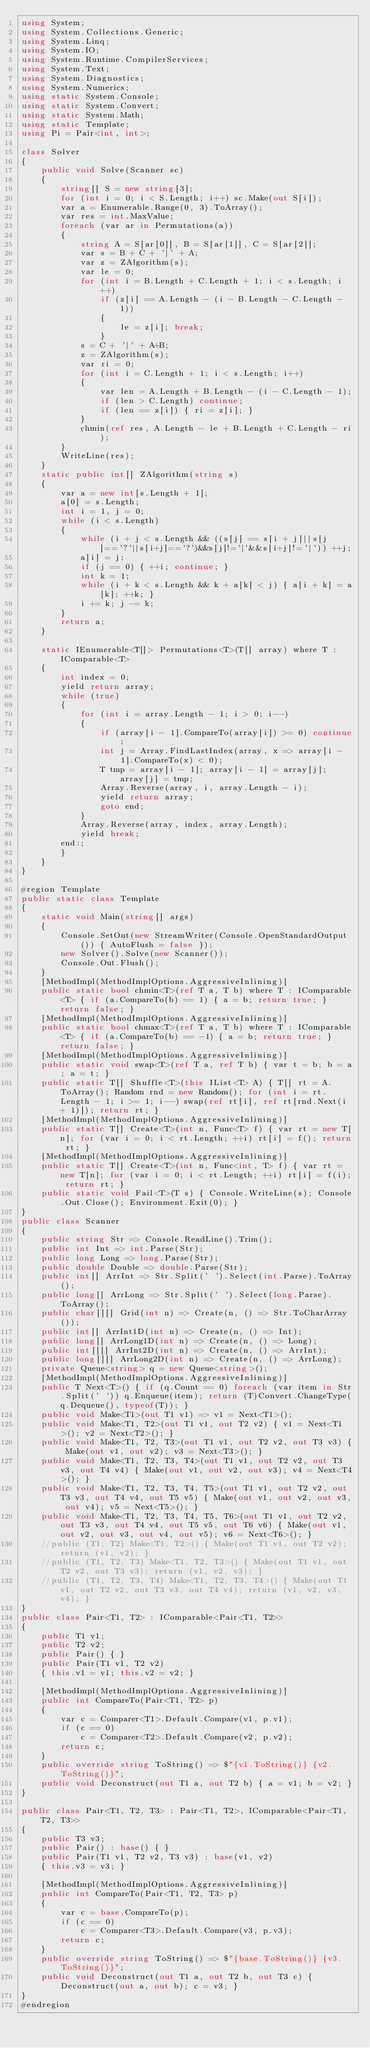<code> <loc_0><loc_0><loc_500><loc_500><_C#_>using System;
using System.Collections.Generic;
using System.Linq;
using System.IO;
using System.Runtime.CompilerServices;
using System.Text;
using System.Diagnostics;
using System.Numerics;
using static System.Console;
using static System.Convert;
using static System.Math;
using static Template;
using Pi = Pair<int, int>;

class Solver
{
    public void Solve(Scanner sc)
    {
        string[] S = new string[3];
        for (int i = 0; i < S.Length; i++) sc.Make(out S[i]);
        var a = Enumerable.Range(0, 3).ToArray();
        var res = int.MaxValue;
        foreach (var ar in Permutations(a))
        {
            string A = S[ar[0]], B = S[ar[1]], C = S[ar[2]];
            var s = B + C + '|' + A;
            var z = ZAlgorithm(s);
            var le = 0;
            for (int i = B.Length + C.Length + 1; i < s.Length; i++)
                if (z[i] == A.Length - (i - B.Length - C.Length - 1))
                {
                    le = z[i]; break;
                }
            s = C + '|' + A+B;
            z = ZAlgorithm(s);
            var ri = 0;
            for (int i = C.Length + 1; i < s.Length; i++)
            {
                var len = A.Length + B.Length - (i - C.Length - 1);
                if (len > C.Length) continue;
                if (len == z[i]) { ri = z[i]; }
            }
            chmin(ref res, A.Length - le + B.Length + C.Length - ri);
        }
        WriteLine(res);
    }
    static public int[] ZAlgorithm(string s)
    {
        var a = new int[s.Length + 1];
        a[0] = s.Length;
        int i = 1, j = 0;
        while (i < s.Length)
        {
            while (i + j < s.Length && ((s[j] == s[i + j]||s[j]=='?'||s[i+j]=='?')&&s[j]!='|'&&s[i+j]!='|')) ++j;
            a[i] = j;
            if (j == 0) { ++i; continue; }
            int k = 1;
            while (i + k < s.Length && k + a[k] < j) { a[i + k] = a[k]; ++k; }
            i += k; j -= k;
        }
        return a;
    }

    static IEnumerable<T[]> Permutations<T>(T[] array) where T : IComparable<T>
    {
        int index = 0;
        yield return array;
        while (true)
        {
            for (int i = array.Length - 1; i > 0; i--)
            {
                if (array[i - 1].CompareTo(array[i]) >= 0) continue;
                int j = Array.FindLastIndex(array, x => array[i - 1].CompareTo(x) < 0);
                T tmp = array[i - 1]; array[i - 1] = array[j]; array[j] = tmp;
                Array.Reverse(array, i, array.Length - i);
                yield return array;
                goto end;
            }
            Array.Reverse(array, index, array.Length);
            yield break;
        end:;
        }
    }
}

#region Template
public static class Template
{
    static void Main(string[] args)
    {
        Console.SetOut(new StreamWriter(Console.OpenStandardOutput()) { AutoFlush = false });
        new Solver().Solve(new Scanner());
        Console.Out.Flush();
    }
    [MethodImpl(MethodImplOptions.AggressiveInlining)]
    public static bool chmin<T>(ref T a, T b) where T : IComparable<T> { if (a.CompareTo(b) == 1) { a = b; return true; } return false; }
    [MethodImpl(MethodImplOptions.AggressiveInlining)]
    public static bool chmax<T>(ref T a, T b) where T : IComparable<T> { if (a.CompareTo(b) == -1) { a = b; return true; } return false; }
    [MethodImpl(MethodImplOptions.AggressiveInlining)]
    public static void swap<T>(ref T a, ref T b) { var t = b; b = a; a = t; }
    public static T[] Shuffle<T>(this IList<T> A) { T[] rt = A.ToArray(); Random rnd = new Random(); for (int i = rt.Length - 1; i >= 1; i--) swap(ref rt[i], ref rt[rnd.Next(i + 1)]); return rt; }
    [MethodImpl(MethodImplOptions.AggressiveInlining)]
    public static T[] Create<T>(int n, Func<T> f) { var rt = new T[n]; for (var i = 0; i < rt.Length; ++i) rt[i] = f(); return rt; }
    [MethodImpl(MethodImplOptions.AggressiveInlining)]
    public static T[] Create<T>(int n, Func<int, T> f) { var rt = new T[n]; for (var i = 0; i < rt.Length; ++i) rt[i] = f(i); return rt; }
    public static void Fail<T>(T s) { Console.WriteLine(s); Console.Out.Close(); Environment.Exit(0); }
}
public class Scanner
{
    public string Str => Console.ReadLine().Trim();
    public int Int => int.Parse(Str);
    public long Long => long.Parse(Str);
    public double Double => double.Parse(Str);
    public int[] ArrInt => Str.Split(' ').Select(int.Parse).ToArray();
    public long[] ArrLong => Str.Split(' ').Select(long.Parse).ToArray();
    public char[][] Grid(int n) => Create(n, () => Str.ToCharArray());
    public int[] ArrInt1D(int n) => Create(n, () => Int);
    public long[] ArrLong1D(int n) => Create(n, () => Long);
    public int[][] ArrInt2D(int n) => Create(n, () => ArrInt);
    public long[][] ArrLong2D(int n) => Create(n, () => ArrLong);
    private Queue<string> q = new Queue<string>();
    [MethodImpl(MethodImplOptions.AggressiveInlining)]
    public T Next<T>() { if (q.Count == 0) foreach (var item in Str.Split(' ')) q.Enqueue(item); return (T)Convert.ChangeType(q.Dequeue(), typeof(T)); }
    public void Make<T1>(out T1 v1) => v1 = Next<T1>();
    public void Make<T1, T2>(out T1 v1, out T2 v2) { v1 = Next<T1>(); v2 = Next<T2>(); }
    public void Make<T1, T2, T3>(out T1 v1, out T2 v2, out T3 v3) { Make(out v1, out v2); v3 = Next<T3>(); }
    public void Make<T1, T2, T3, T4>(out T1 v1, out T2 v2, out T3 v3, out T4 v4) { Make(out v1, out v2, out v3); v4 = Next<T4>(); }
    public void Make<T1, T2, T3, T4, T5>(out T1 v1, out T2 v2, out T3 v3, out T4 v4, out T5 v5) { Make(out v1, out v2, out v3, out v4); v5 = Next<T5>(); }
    public void Make<T1, T2, T3, T4, T5, T6>(out T1 v1, out T2 v2, out T3 v3, out T4 v4, out T5 v5, out T6 v6) { Make(out v1, out v2, out v3, out v4, out v5); v6 = Next<T6>(); }
    //public (T1, T2) Make<T1, T2>() { Make(out T1 v1, out T2 v2); return (v1, v2); }
    //public (T1, T2, T3) Make<T1, T2, T3>() { Make(out T1 v1, out T2 v2, out T3 v3); return (v1, v2, v3); }
    //public (T1, T2, T3, T4) Make<T1, T2, T3, T4>() { Make(out T1 v1, out T2 v2, out T3 v3, out T4 v4); return (v1, v2, v3, v4); }
}
public class Pair<T1, T2> : IComparable<Pair<T1, T2>>
{
    public T1 v1;
    public T2 v2;
    public Pair() { }
    public Pair(T1 v1, T2 v2)
    { this.v1 = v1; this.v2 = v2; }

    [MethodImpl(MethodImplOptions.AggressiveInlining)]
    public int CompareTo(Pair<T1, T2> p)
    {
        var c = Comparer<T1>.Default.Compare(v1, p.v1);
        if (c == 0)
            c = Comparer<T2>.Default.Compare(v2, p.v2);
        return c;
    }
    public override string ToString() => $"{v1.ToString()} {v2.ToString()}";
    public void Deconstruct(out T1 a, out T2 b) { a = v1; b = v2; }
}

public class Pair<T1, T2, T3> : Pair<T1, T2>, IComparable<Pair<T1, T2, T3>>
{
    public T3 v3;
    public Pair() : base() { }
    public Pair(T1 v1, T2 v2, T3 v3) : base(v1, v2)
    { this.v3 = v3; }

    [MethodImpl(MethodImplOptions.AggressiveInlining)]
    public int CompareTo(Pair<T1, T2, T3> p)
    {
        var c = base.CompareTo(p);
        if (c == 0)
            c = Comparer<T3>.Default.Compare(v3, p.v3);
        return c;
    }
    public override string ToString() => $"{base.ToString()} {v3.ToString()}";
    public void Deconstruct(out T1 a, out T2 b, out T3 c) { Deconstruct(out a, out b); c = v3; }
}
#endregion</code> 